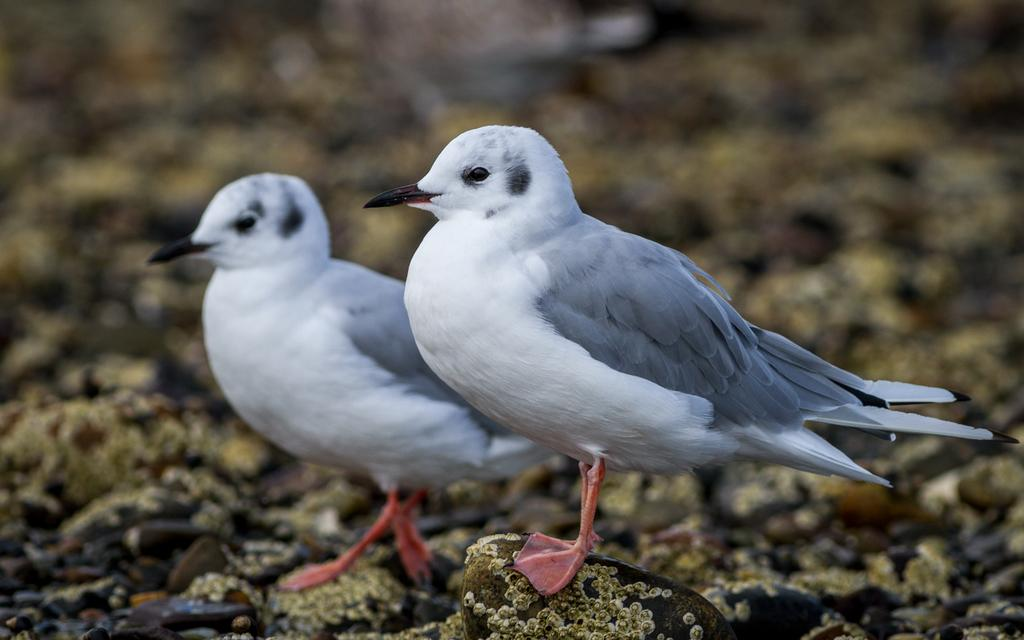What animals are present in the image? There are two birds in the image. Where are the birds located in the image? The birds are on stones at the bottom of the image. Can you describe the background of the image? The background of the image is blurred. What caption is written below the birds in the image? There is no caption present in the image. How are the birds being transported in the image? The birds are not being transported in the image; they are perched on stones. 